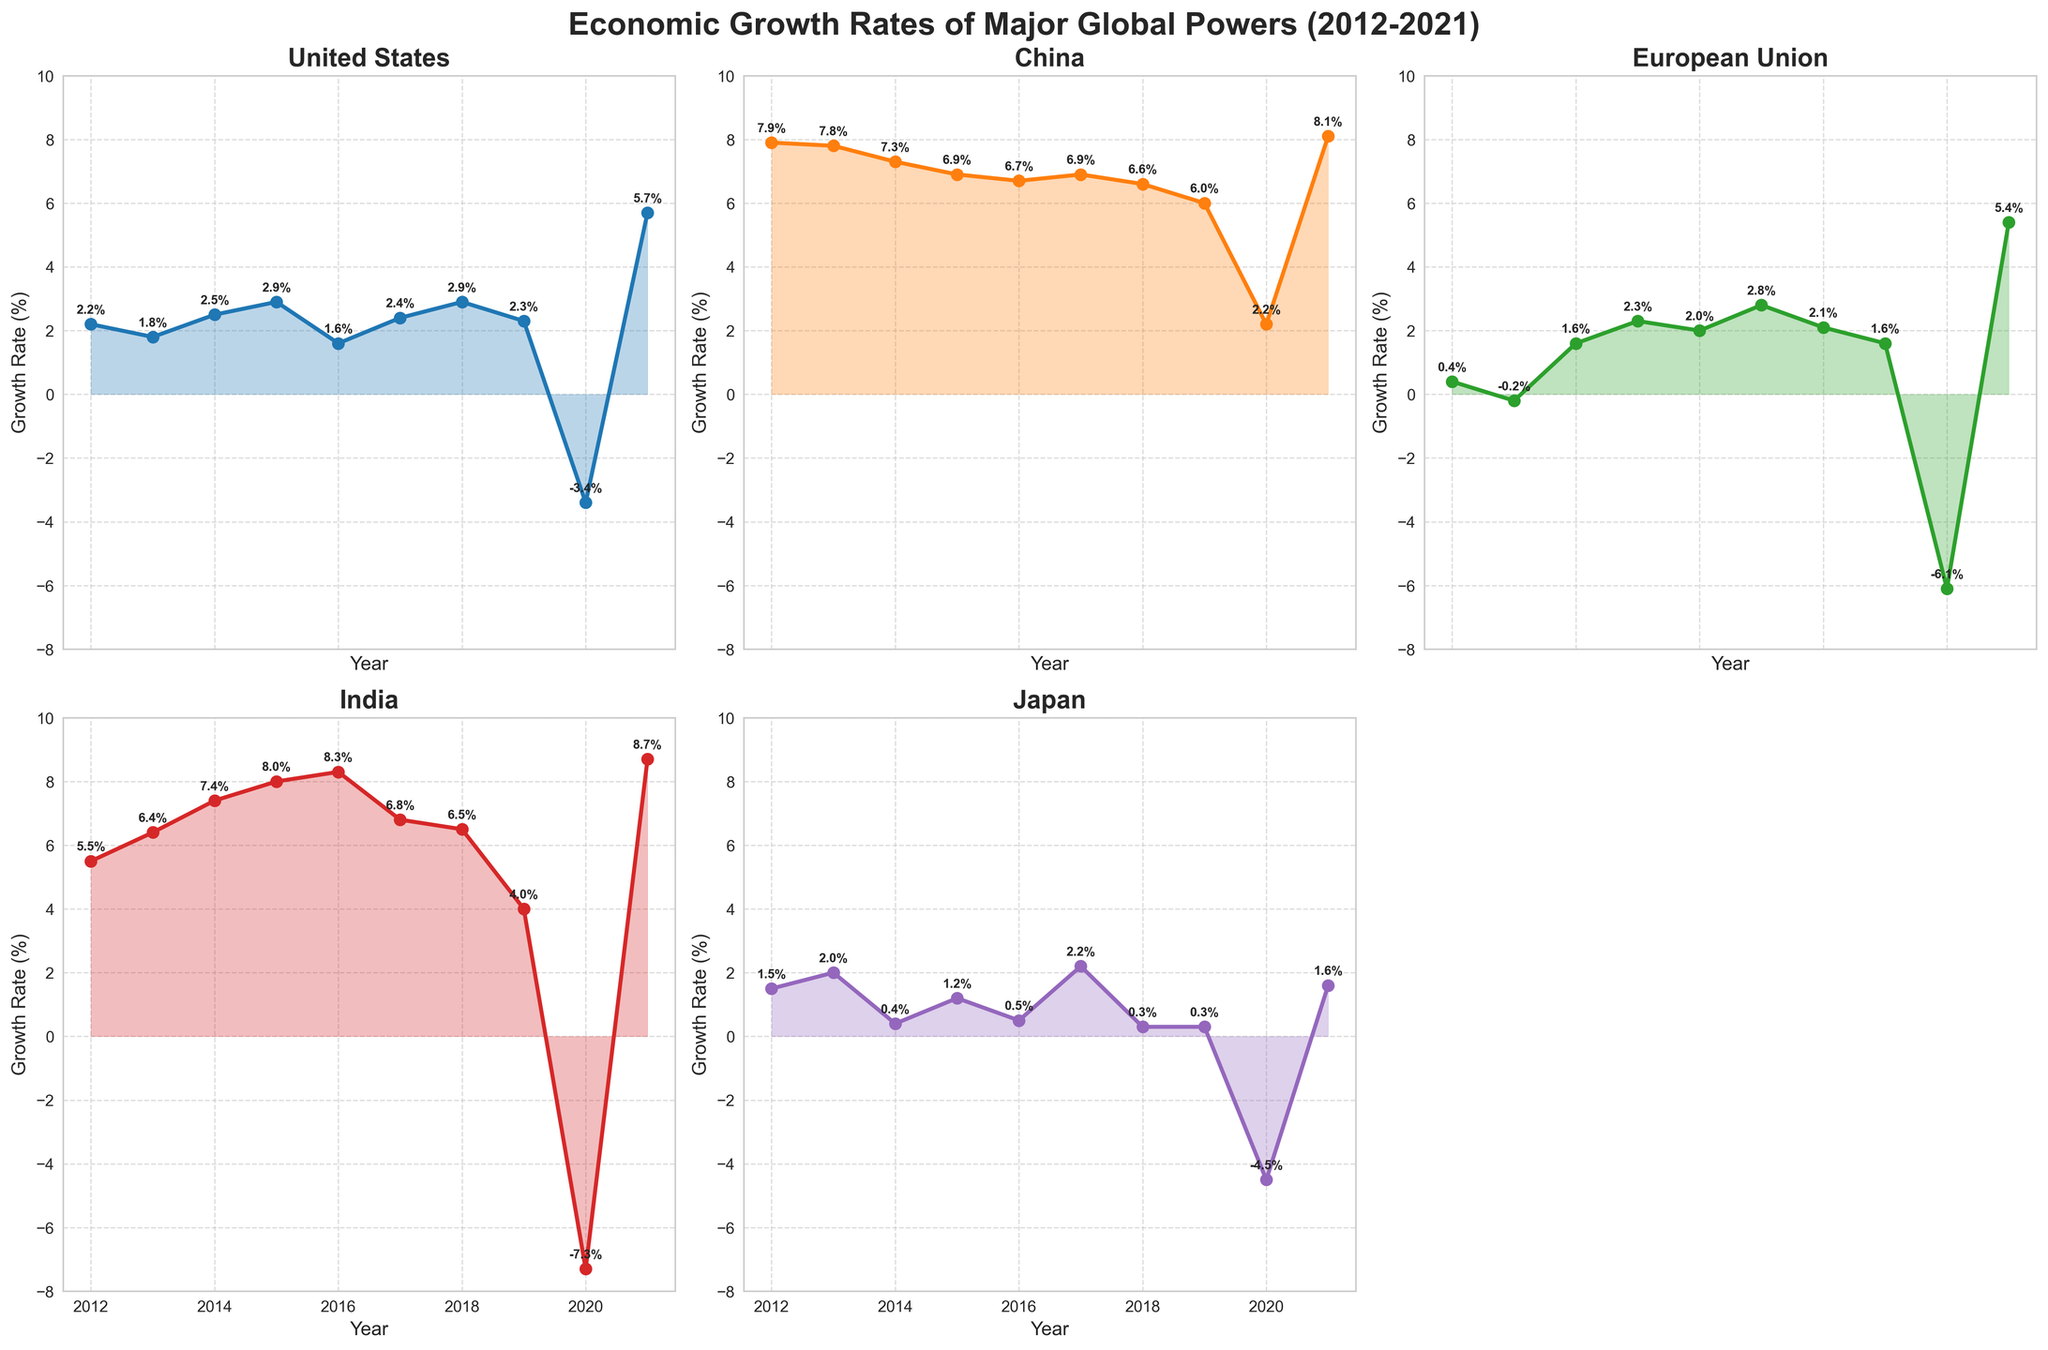How many subplots are there in total? There are a total of six subplots, as inferred from the 2x3 grid layout shown in the figure. However, one subplot (the last one on the bottom right) has been removed, leaving five active subplots.
Answer: Five Which country experienced the highest growth rate in any given year? By inspecting the subplots for the peak points, India exhibits the highest growth rate of 8.7% in 2021.
Answer: India What was the general trend of the United States' economic growth rate from 2012 to 2021? To analyze the trend, note the growth rates plotted on the graph for the United States from 2012 to 2021. The trend appears to fluctuate with an overall pattern of modest growth, a significant decline in 2020, followed by a rebound in 2021.
Answer: Fluctuating with a dip in 2020 and rebound in 2021 Which two countries experienced negative growth rates in 2020? Inspecting the subplots for 2020 data points, the United States and the European Union show negative growth rates of -3.4% and -6.1%, respectively.
Answer: United States and European Union What was the difference in economic growth rates between China and Japan in 2020? Looking at the subplots for 2020, China's growth rate was 2.2% and Japan's was -4.5%. The difference can be calculated as 2.2 - (-4.5) = 6.7.
Answer: 6.7% Which country showed the highest growth rate recovery from 2020 to 2021? By comparing the growth rate changes from 2020 to 2021 in each subplot, India shows the highest recovery, moving from -7.3% in 2020 to 8.7% in 2021, which is a change of 16%.
Answer: India What's the average growth rate of the European Union from 2012 to 2021? The yearly growth rates for the European Union are 0.4, -0.2, 1.6, 2.3, 2.0, 2.8, 2.1, 1.6, -6.1, and 5.4. Summing these up gives 11.9. Dividing by the number of years (10) gives an average of 11.9/10 = 1.19%.
Answer: 1.19% Which country showed the most consistent (least fluctuating) economic growth over the years? Visual inspection of the subplots shows that China's growth rates vary the least, staying generally between 7.9% and 6.0% except in 2020 when it dropped to 2.2%.
Answer: China Did any country’s economic growth rate exclusively increase every year from 2012 to 2021? Upon inspection of the subplots, none of the countries show an uninterrupted yearly increase in economic growth rates from 2012 to 2021. All countries have at least one year where the growth rate decreased.
Answer: No From 2014 to 2015, which country had the largest increase in economic growth rate? For 2014 to 2015, comparing the growth rates of all subplots, India shows the largest increase, moving from 7.4% in 2014 to 8.0% in 2015, an increase of 0.6%.
Answer: India 